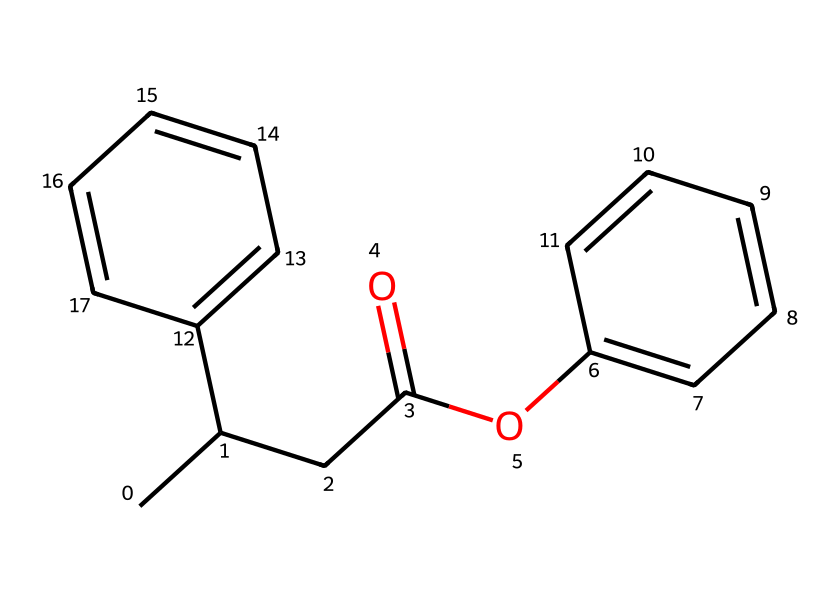What is the primary functional group present in this compound? The compound features an ester functional group, observable by the presence of the -OC(=O)- part in its structure, which is characteristic of esters.
Answer: ester How many rings are present in the structure of this chemical? By examining the structure, there are two distinct cyclic structures (rings) evident in the SMILES notation, specifically two benzene rings.
Answer: two What is the total number of carbon atoms in the chemical? Counting the carbon atoms from the entire structure indicated by the SMILES, there are 16 carbon atoms present in this compound.
Answer: 16 What type of drug classification does this compound belong to? The structure shows characteristics typical of nonsteroidal anti-inflammatory drugs (NSAIDs), which are designed to reduce inflammation and pain, especially for athletic injuries.
Answer: NSAID Does this compound contain any nitrogen atoms? Analyzing the SMILES, there are no nitrogen atoms present in the chemical structure, making it entirely carbon and hydrogen based without nitrogen.
Answer: no How many double bonds does this chemical structure contain? Upon careful inspection of the SMILES, it reveals 4 double bonds that are identifiable in the different parts of the structure, with each double bond typically found in the aromatic rings and the ester moiety.
Answer: 4 What could be the medicinal role of this compound? Given its classification as a nonsteroidal anti-inflammatory drug (NSAID), this compound is used primarily for pain relief and reduction of inflammation, particularly relevant for treating athletic injuries.
Answer: pain relief 